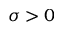<formula> <loc_0><loc_0><loc_500><loc_500>\sigma > 0</formula> 